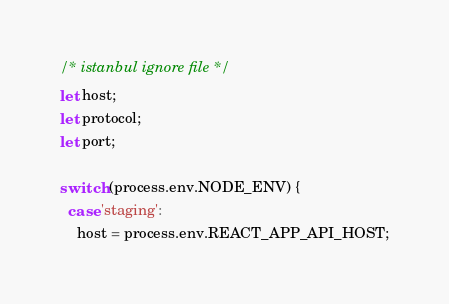Convert code to text. <code><loc_0><loc_0><loc_500><loc_500><_JavaScript_>/* istanbul ignore file */
let host;
let protocol;
let port;

switch (process.env.NODE_ENV) {
  case 'staging':
    host = process.env.REACT_APP_API_HOST;</code> 